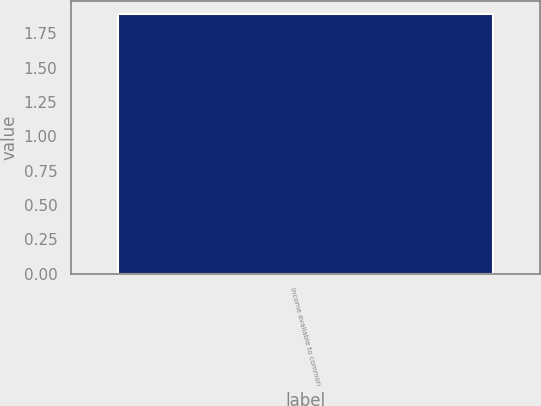Convert chart. <chart><loc_0><loc_0><loc_500><loc_500><bar_chart><fcel>Income available to common<nl><fcel>1.89<nl></chart> 